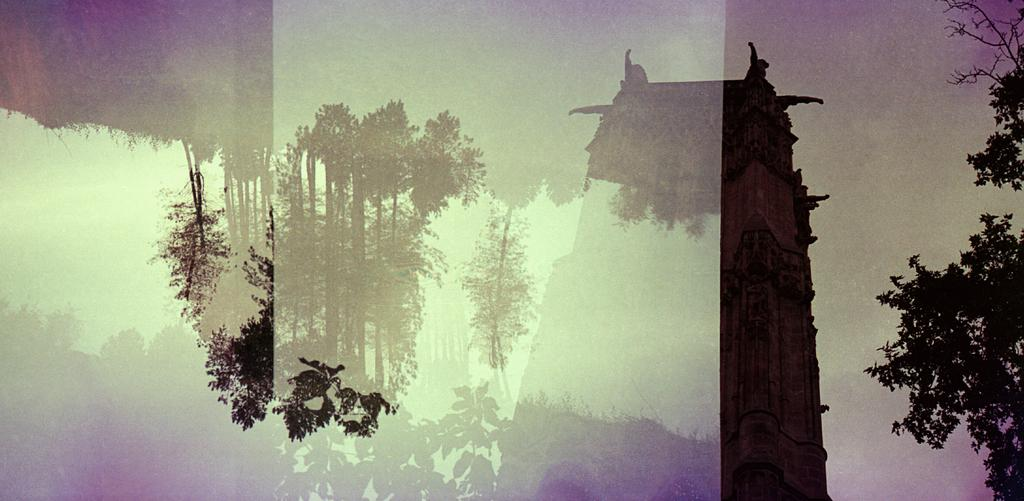What type of structure is present in the image? There is a building in the image. What other natural elements can be seen in the image? There are trees in the image. What can be seen in the distance in the image? The sky is visible in the background of the image. Where is the park located in the image? There is no park present in the image. What type of lunch is being served in the image? There is no lunch present in the image. 